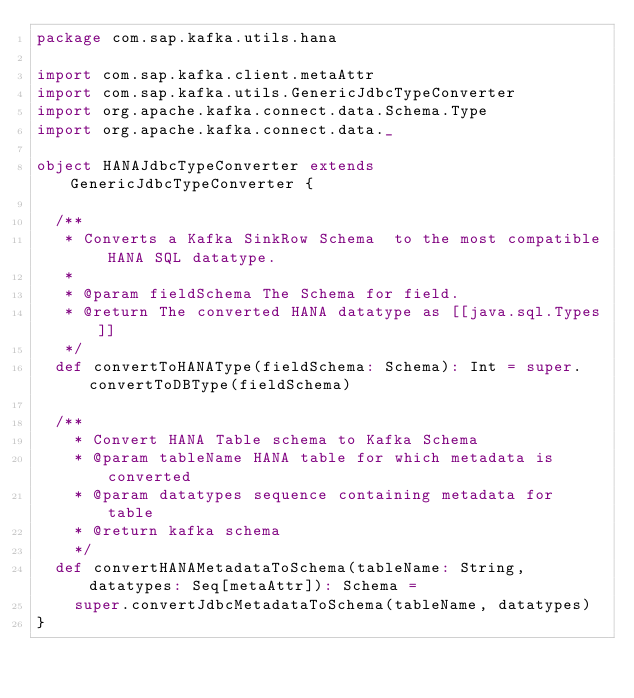<code> <loc_0><loc_0><loc_500><loc_500><_Scala_>package com.sap.kafka.utils.hana

import com.sap.kafka.client.metaAttr
import com.sap.kafka.utils.GenericJdbcTypeConverter
import org.apache.kafka.connect.data.Schema.Type
import org.apache.kafka.connect.data._

object HANAJdbcTypeConverter extends GenericJdbcTypeConverter {

  /**
   * Converts a Kafka SinkRow Schema  to the most compatible HANA SQL datatype.
   *
   * @param fieldSchema The Schema for field.
   * @return The converted HANA datatype as [[java.sql.Types]]
   */
  def convertToHANAType(fieldSchema: Schema): Int = super.convertToDBType(fieldSchema)

  /**
    * Convert HANA Table schema to Kafka Schema
    * @param tableName HANA table for which metadata is converted
    * @param datatypes sequence containing metadata for table
    * @return kafka schema
    */
  def convertHANAMetadataToSchema(tableName: String, datatypes: Seq[metaAttr]): Schema =
    super.convertJdbcMetadataToSchema(tableName, datatypes)
}
</code> 